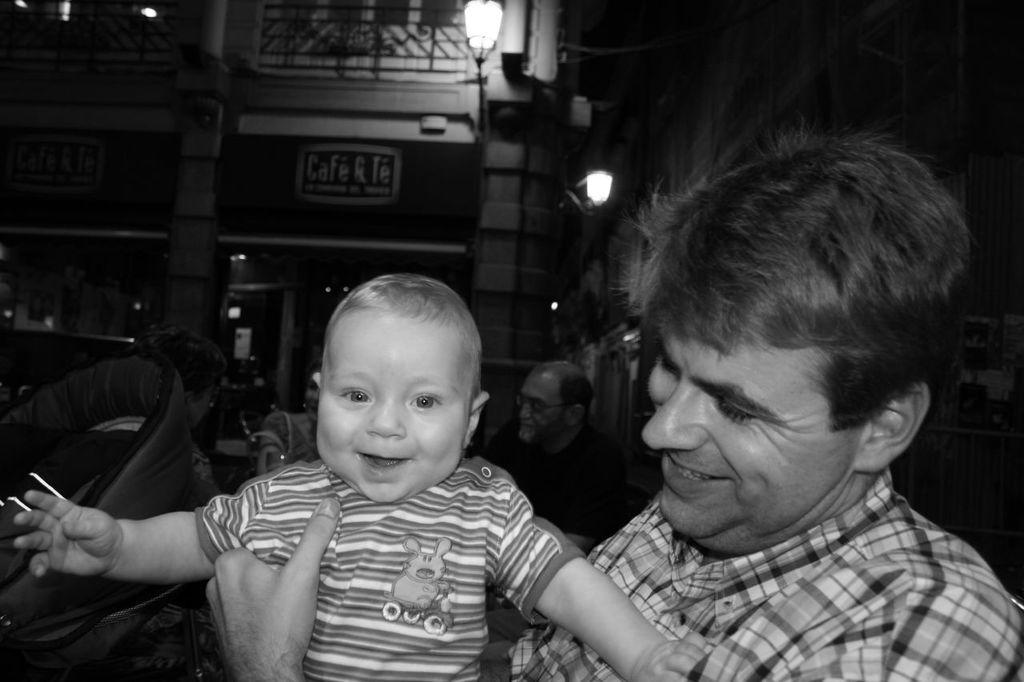What is the main subject in the center of the image? There is a man standing in the center of the image. What is the man holding in his hand? The man is holding a baby in his hand. What can be seen on the left side of the image? There is a chair on the left side of the image. What is visible in the background of the image? There are people, buildings, and lights in the background of the image. What type of boundary can be seen in the image? There is no boundary present in the image. Can you tell me how many matches are visible in the image? There are no matches present in the image. 